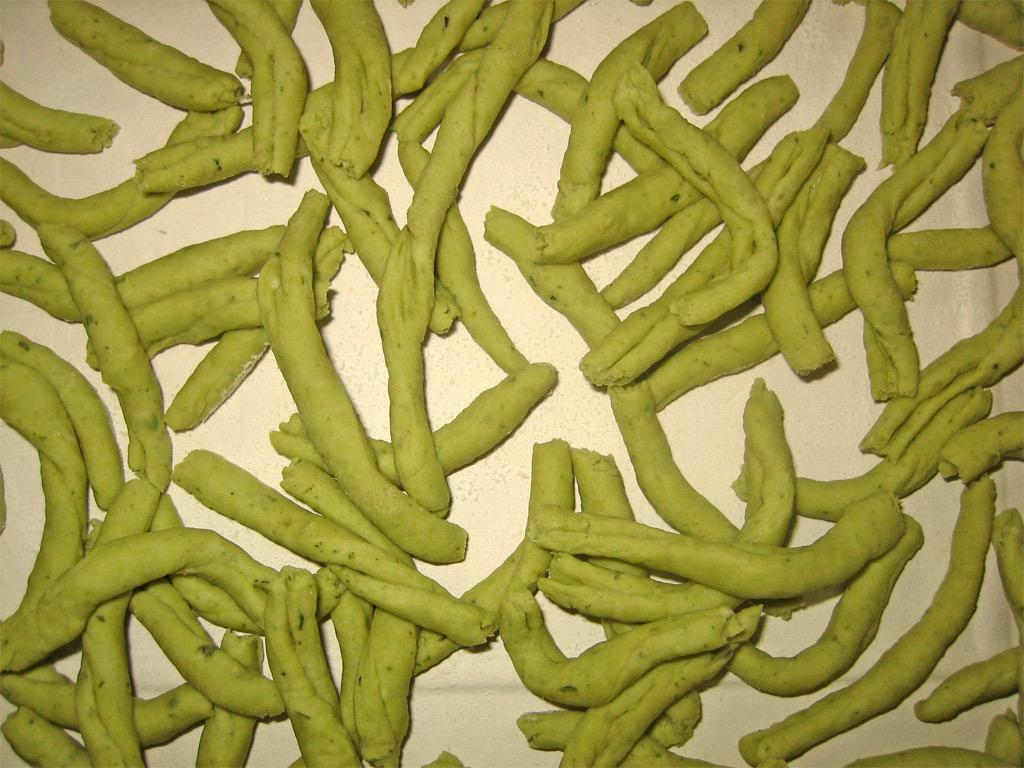What is the main subject of the image? There is a food item in the image. What type of mitten is being used to prepare the food item in the image? There is no mitten present in the image, as it only features a food item. 